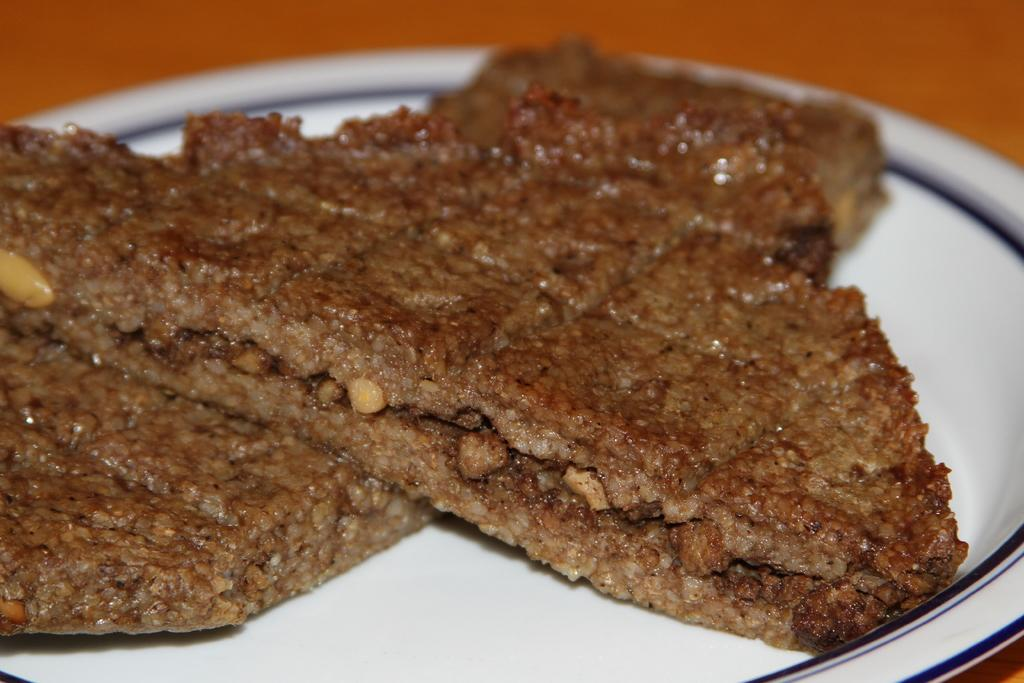What is on the plate that is visible in the image? There are cookies and dry fruits on the plate. What color is the plate in the image? The plate is white in color. What color are the cookies on the plate? The cookies are brown in color. What other items can be seen on the plate besides cookies? There are dry fruits on the plate. How does the plate feel to the touch in the image? The image does not provide information about how the plate feels to the touch, as it is a visual representation. 